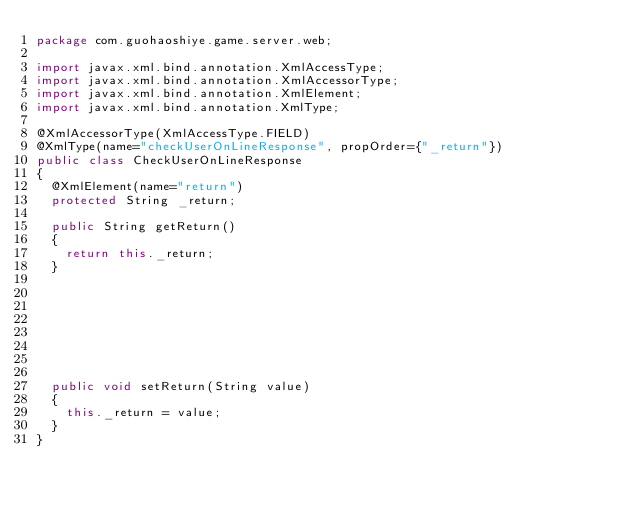<code> <loc_0><loc_0><loc_500><loc_500><_Java_>package com.guohaoshiye.game.server.web;

import javax.xml.bind.annotation.XmlAccessType;
import javax.xml.bind.annotation.XmlAccessorType;
import javax.xml.bind.annotation.XmlElement;
import javax.xml.bind.annotation.XmlType;

@XmlAccessorType(XmlAccessType.FIELD)
@XmlType(name="checkUserOnLineResponse", propOrder={"_return"})
public class CheckUserOnLineResponse
{
  @XmlElement(name="return")
  protected String _return;

  public String getReturn()
  {
    return this._return;
  }








  public void setReturn(String value)
  {
    this._return = value;
  }
}

</code> 